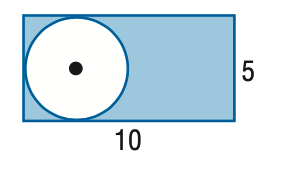Answer the mathemtical geometry problem and directly provide the correct option letter.
Question: Find the area of the shaded region. Assume that all polygons that appear to be regular are regular. Round to the nearest tenth.
Choices: A: 25 B: 28.5 C: 30.4 D: 50 C 